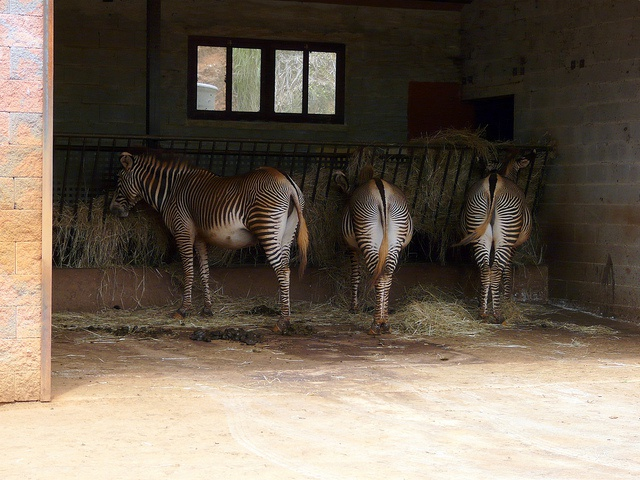Describe the objects in this image and their specific colors. I can see zebra in lightpink, black, maroon, and gray tones, zebra in lightpink, black, gray, darkgray, and maroon tones, and zebra in lightpink, black, and gray tones in this image. 